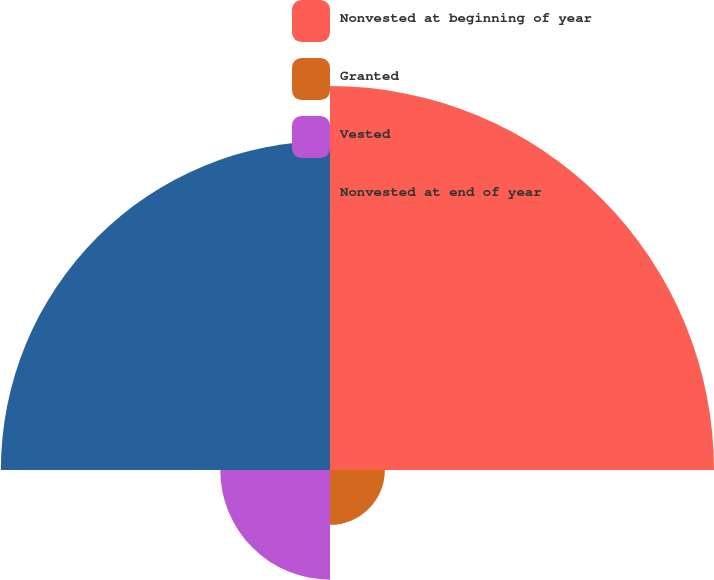Convert chart to OTSL. <chart><loc_0><loc_0><loc_500><loc_500><pie_chart><fcel>Nonvested at beginning of year<fcel>Granted<fcel>Vested<fcel>Nonvested at end of year<nl><fcel>43.75%<fcel>6.25%<fcel>12.5%<fcel>37.5%<nl></chart> 